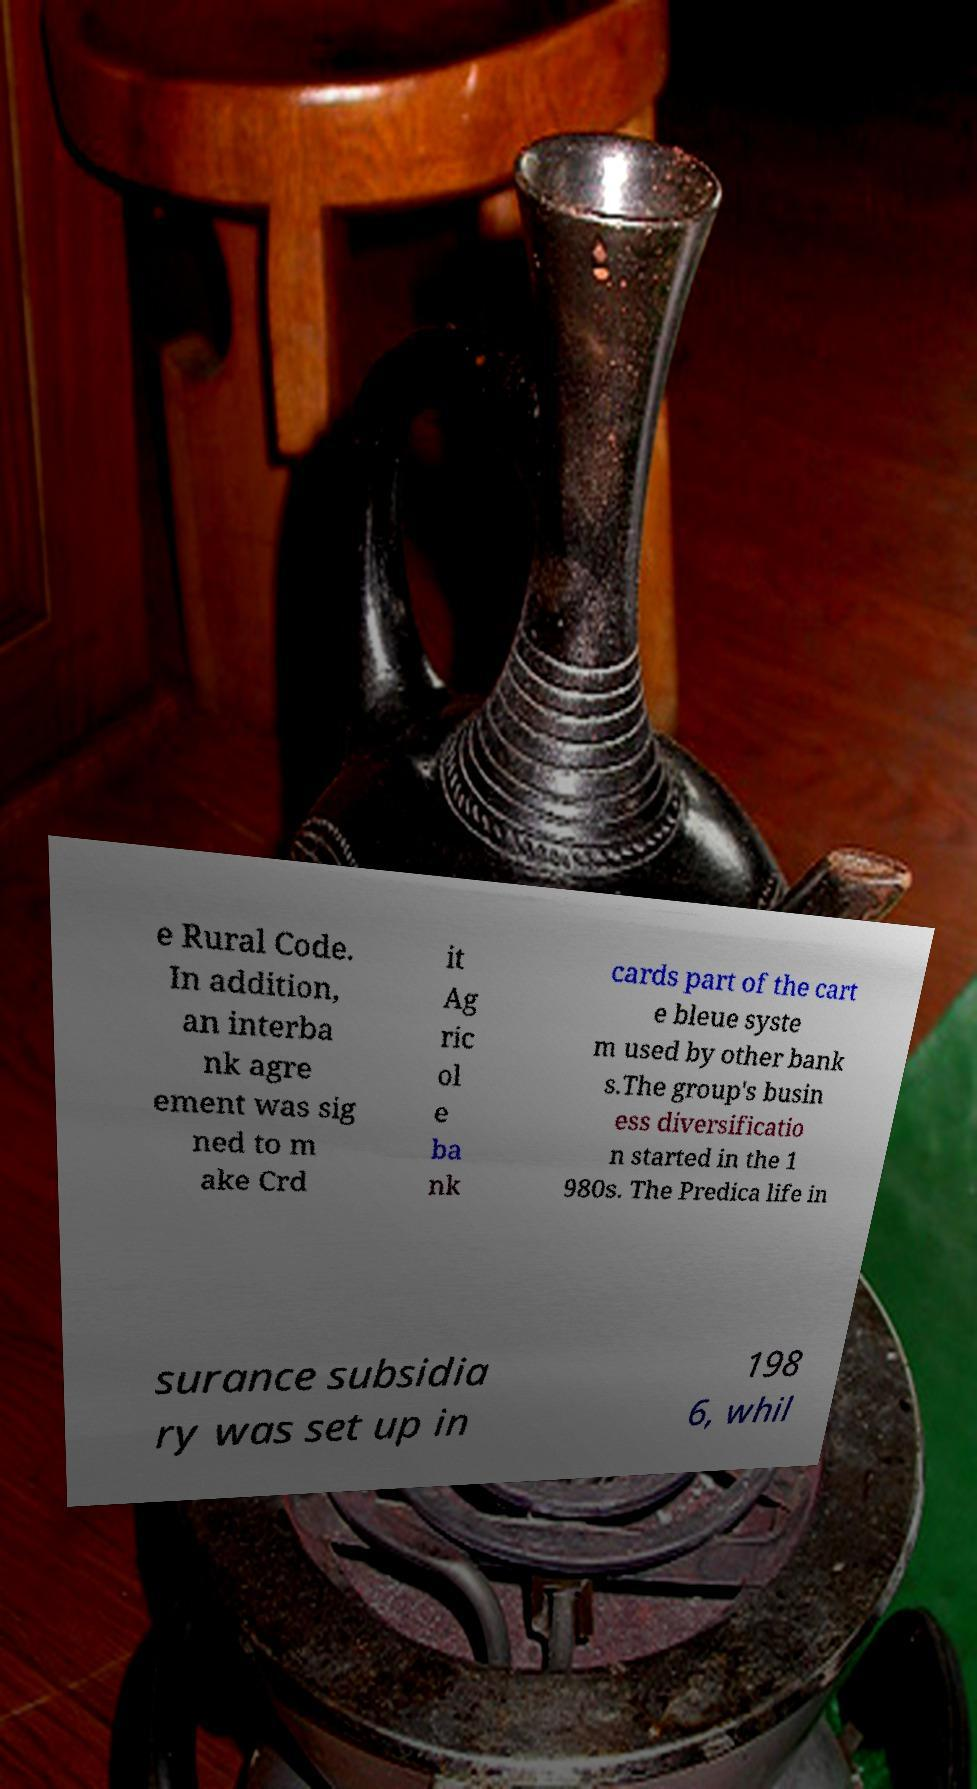What messages or text are displayed in this image? I need them in a readable, typed format. e Rural Code. In addition, an interba nk agre ement was sig ned to m ake Crd it Ag ric ol e ba nk cards part of the cart e bleue syste m used by other bank s.The group's busin ess diversificatio n started in the 1 980s. The Predica life in surance subsidia ry was set up in 198 6, whil 